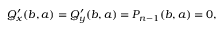Convert formula to latex. <formula><loc_0><loc_0><loc_500><loc_500>Q _ { x } ^ { \prime } ( b , a ) = Q _ { y } ^ { \prime } ( b , a ) = P _ { n - 1 } ( b , a ) = 0 ,</formula> 